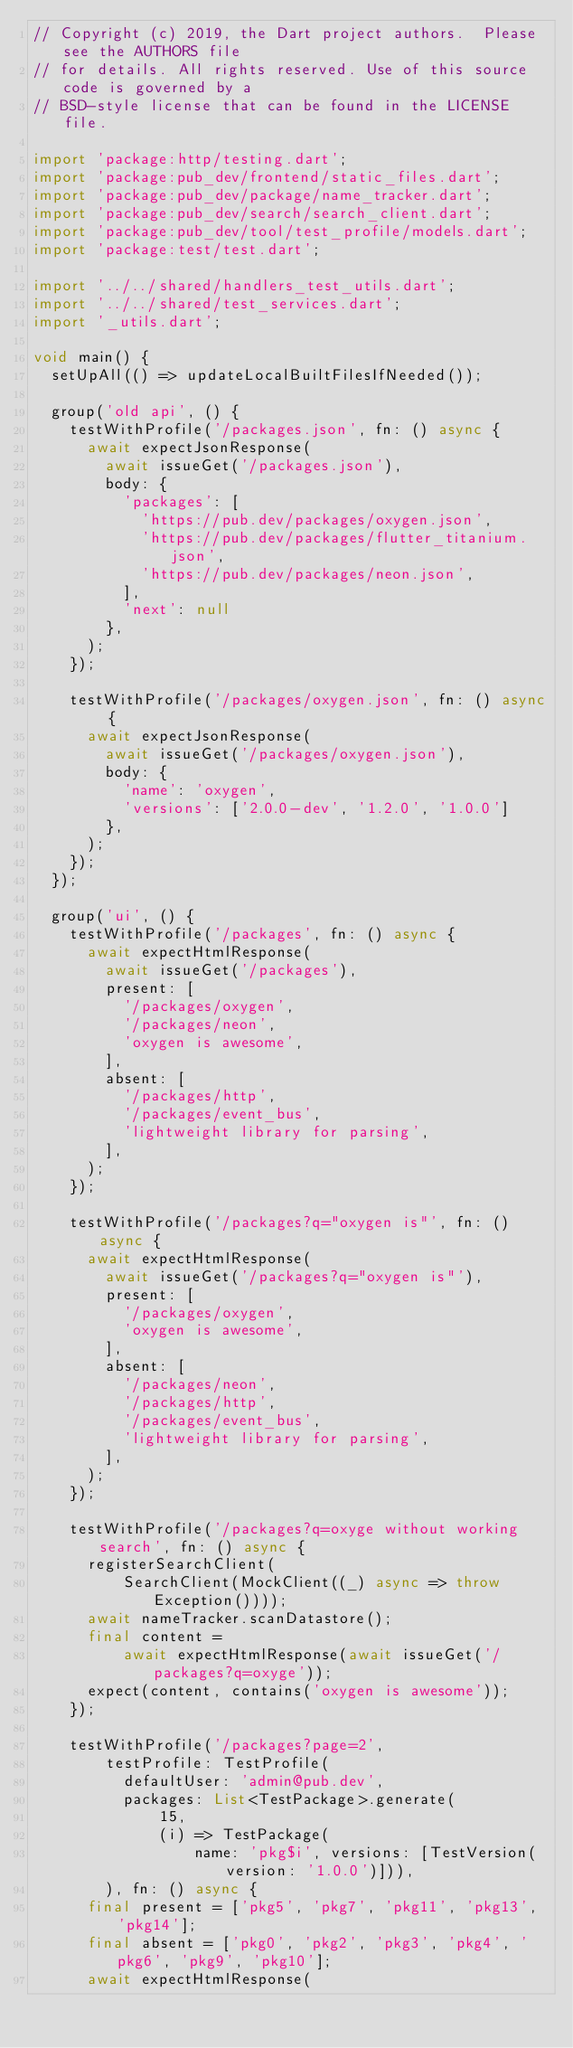<code> <loc_0><loc_0><loc_500><loc_500><_Dart_>// Copyright (c) 2019, the Dart project authors.  Please see the AUTHORS file
// for details. All rights reserved. Use of this source code is governed by a
// BSD-style license that can be found in the LICENSE file.

import 'package:http/testing.dart';
import 'package:pub_dev/frontend/static_files.dart';
import 'package:pub_dev/package/name_tracker.dart';
import 'package:pub_dev/search/search_client.dart';
import 'package:pub_dev/tool/test_profile/models.dart';
import 'package:test/test.dart';

import '../../shared/handlers_test_utils.dart';
import '../../shared/test_services.dart';
import '_utils.dart';

void main() {
  setUpAll(() => updateLocalBuiltFilesIfNeeded());

  group('old api', () {
    testWithProfile('/packages.json', fn: () async {
      await expectJsonResponse(
        await issueGet('/packages.json'),
        body: {
          'packages': [
            'https://pub.dev/packages/oxygen.json',
            'https://pub.dev/packages/flutter_titanium.json',
            'https://pub.dev/packages/neon.json',
          ],
          'next': null
        },
      );
    });

    testWithProfile('/packages/oxygen.json', fn: () async {
      await expectJsonResponse(
        await issueGet('/packages/oxygen.json'),
        body: {
          'name': 'oxygen',
          'versions': ['2.0.0-dev', '1.2.0', '1.0.0']
        },
      );
    });
  });

  group('ui', () {
    testWithProfile('/packages', fn: () async {
      await expectHtmlResponse(
        await issueGet('/packages'),
        present: [
          '/packages/oxygen',
          '/packages/neon',
          'oxygen is awesome',
        ],
        absent: [
          '/packages/http',
          '/packages/event_bus',
          'lightweight library for parsing',
        ],
      );
    });

    testWithProfile('/packages?q="oxygen is"', fn: () async {
      await expectHtmlResponse(
        await issueGet('/packages?q="oxygen is"'),
        present: [
          '/packages/oxygen',
          'oxygen is awesome',
        ],
        absent: [
          '/packages/neon',
          '/packages/http',
          '/packages/event_bus',
          'lightweight library for parsing',
        ],
      );
    });

    testWithProfile('/packages?q=oxyge without working search', fn: () async {
      registerSearchClient(
          SearchClient(MockClient((_) async => throw Exception())));
      await nameTracker.scanDatastore();
      final content =
          await expectHtmlResponse(await issueGet('/packages?q=oxyge'));
      expect(content, contains('oxygen is awesome'));
    });

    testWithProfile('/packages?page=2',
        testProfile: TestProfile(
          defaultUser: 'admin@pub.dev',
          packages: List<TestPackage>.generate(
              15,
              (i) => TestPackage(
                  name: 'pkg$i', versions: [TestVersion(version: '1.0.0')])),
        ), fn: () async {
      final present = ['pkg5', 'pkg7', 'pkg11', 'pkg13', 'pkg14'];
      final absent = ['pkg0', 'pkg2', 'pkg3', 'pkg4', 'pkg6', 'pkg9', 'pkg10'];
      await expectHtmlResponse(</code> 